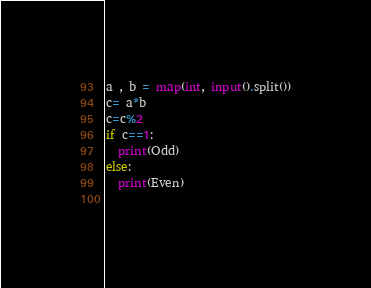<code> <loc_0><loc_0><loc_500><loc_500><_Python_>a , b = map(int, input().split())
c= a*b 
c=c%2
if c==1:
  print(Odd)
else:
  print(Even)
  </code> 